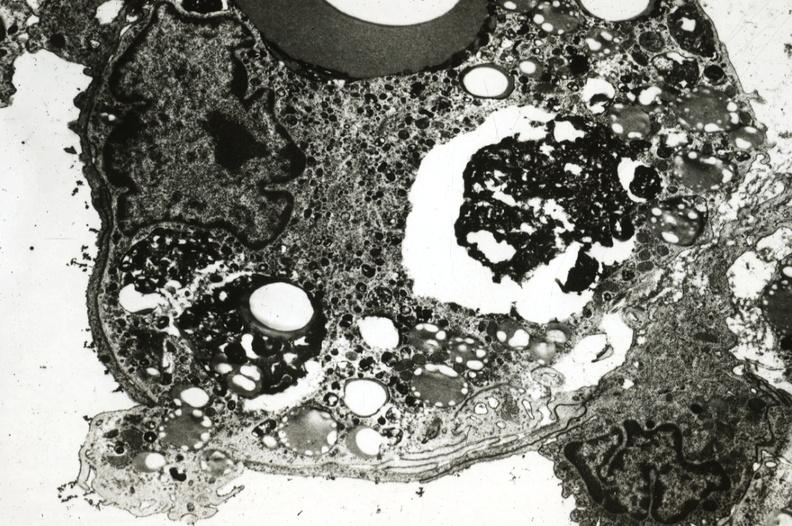s aorta present?
Answer the question using a single word or phrase. Yes 